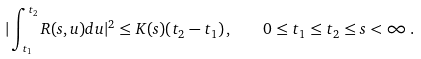Convert formula to latex. <formula><loc_0><loc_0><loc_500><loc_500>| \int _ { t _ { 1 } } ^ { t _ { 2 } } R ( s , u ) d u | ^ { 2 } \leq K ( s ) ( t _ { 2 } - t _ { 1 } ) \, , \quad 0 \leq t _ { 1 } \leq t _ { 2 } \leq s < \infty \, .</formula> 